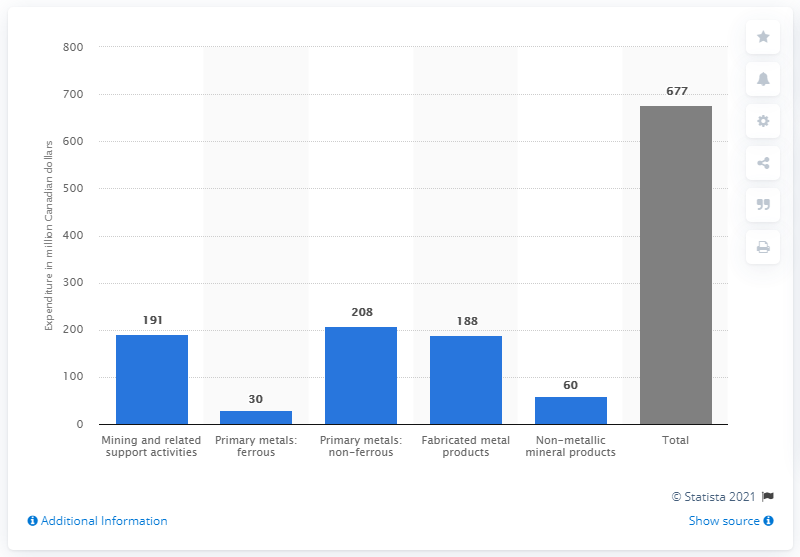List a handful of essential elements in this visual. What is the difference between total and nonmetallic mineral products? In 2013, the total amount of R&D spending in the Canadian mining industry was 677. The value of primary metals, specifically ferrous metals, is 30%. 